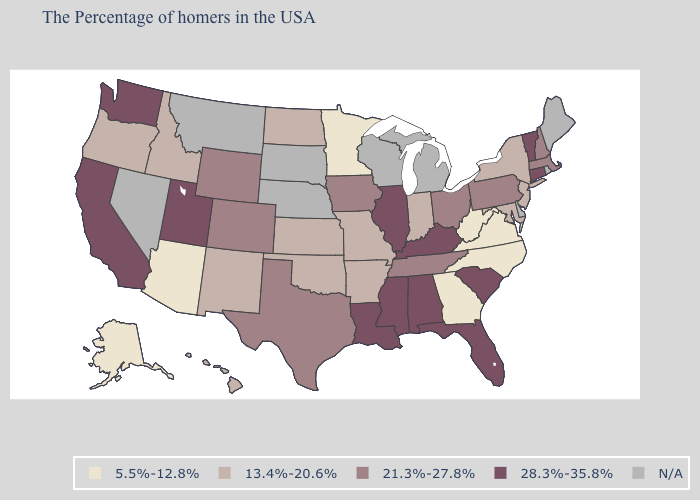Name the states that have a value in the range 28.3%-35.8%?
Concise answer only. Vermont, Connecticut, South Carolina, Florida, Kentucky, Alabama, Illinois, Mississippi, Louisiana, Utah, California, Washington. Does Illinois have the lowest value in the MidWest?
Short answer required. No. Name the states that have a value in the range 5.5%-12.8%?
Be succinct. Virginia, North Carolina, West Virginia, Georgia, Minnesota, Arizona, Alaska. What is the value of New Jersey?
Be succinct. 13.4%-20.6%. Among the states that border West Virginia , does Virginia have the highest value?
Keep it brief. No. Name the states that have a value in the range 21.3%-27.8%?
Keep it brief. Massachusetts, New Hampshire, Pennsylvania, Ohio, Tennessee, Iowa, Texas, Wyoming, Colorado. What is the value of New Hampshire?
Be succinct. 21.3%-27.8%. Which states have the lowest value in the USA?
Write a very short answer. Virginia, North Carolina, West Virginia, Georgia, Minnesota, Arizona, Alaska. Does West Virginia have the highest value in the USA?
Quick response, please. No. Name the states that have a value in the range 5.5%-12.8%?
Be succinct. Virginia, North Carolina, West Virginia, Georgia, Minnesota, Arizona, Alaska. What is the highest value in states that border Alabama?
Give a very brief answer. 28.3%-35.8%. Does the map have missing data?
Concise answer only. Yes. Does Alabama have the highest value in the USA?
Give a very brief answer. Yes. 